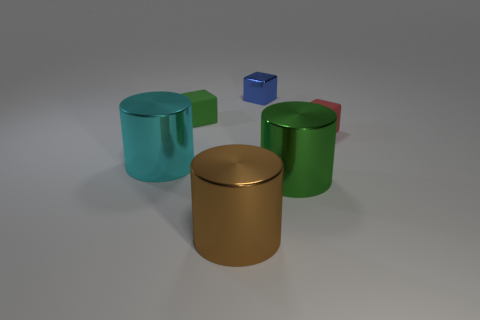Are there any large red objects that have the same material as the big green thing? Upon examining the scene, there are no large red objects with the same material as the green cylindrical container. While there is a small red cube, it does not match the size criteria established in the question. 